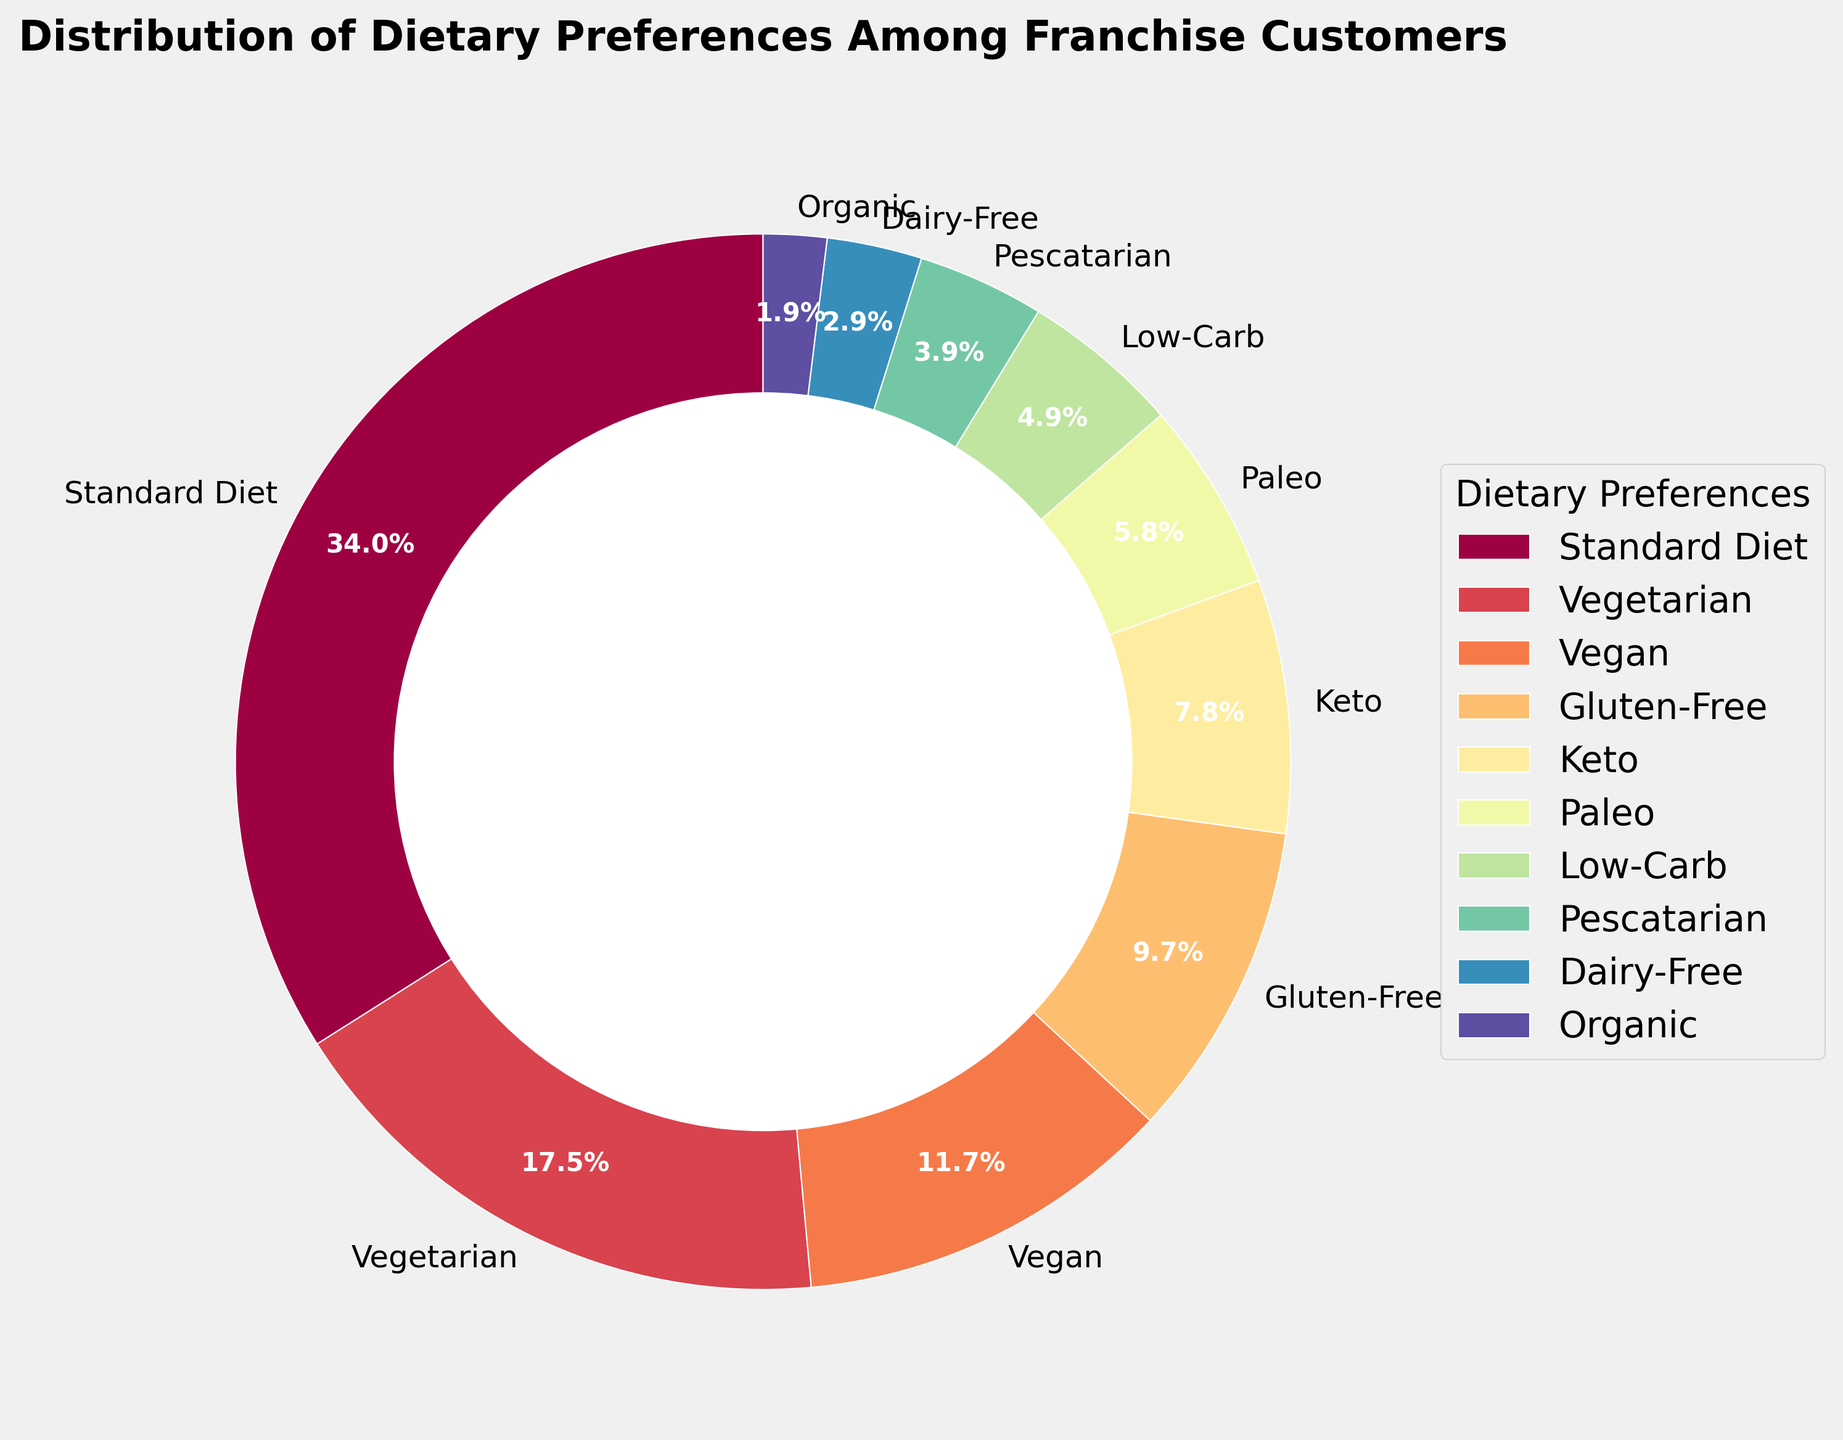What percentage of customers follow a vegetarian diet? The pie chart shows the percentage for each dietary preference. Locate the wedge labeled "Vegetarian" and read off its percentage, which is 18%.
Answer: 18% Which dietary preference is the most common among franchise customers? From the pie chart, find the largest wedge, which is labeled "Standard Diet" with 35%.
Answer: Standard Diet How much larger is the percentage of vegan customers compared to pescatarian customers? Locate the wedges for "Vegan" and "Pescatarian," with percentages 12% and 4%, respectively. Then subtract 4 from 12 to find the difference.
Answer: 8% What is the combined percentage of customers following Paleo and Keto diets? Find the wedges for "Paleo" and "Keto," with percentages 6% and 8%, respectively. Add these percentages together (6 + 8).
Answer: 14% Which dietary preference has the smallest percentage of customers? Find the smallest wedge on the pie chart, which is labeled "Organic" with 2%.
Answer: Organic Do more customers follow a gluten-free diet or a low-carb diet? Compare the wedges for "Gluten-Free" and "Low-Carb." The percentages are 10% for Gluten-Free and 5% for Low-Carb.
Answer: Gluten-Free What are the two most popular dietary preferences after the standard diet? The largest wedge is for "Standard Diet" at 35%. The next largest wedges are "Vegetarian" with 18% and "Vegan" with 12%.
Answer: Vegetarian and Vegan Are there more customers following a dairy-free diet or an organic diet? Compare the wedges for "Dairy-Free" and "Organic." The percentages are 3% for Dairy-Free and 2% for Organic.
Answer: Dairy-Free What percentage of customers follows diets other than the standard diet, vegetarian, or vegan? Add the percentages of all preferences except for "Standard Diet," "Vegetarian," and "Vegan." (10+8+6+5+4+3+2).
Answer: 38% How does the percentage of low-carb customers compare to pescatarian customers? Compare the wedges for "Low-Carb" and "Pescatarian." The percentages are 5% for Low-Carb and 4% for Pescatarian.
Answer: Low-Carb is higher 